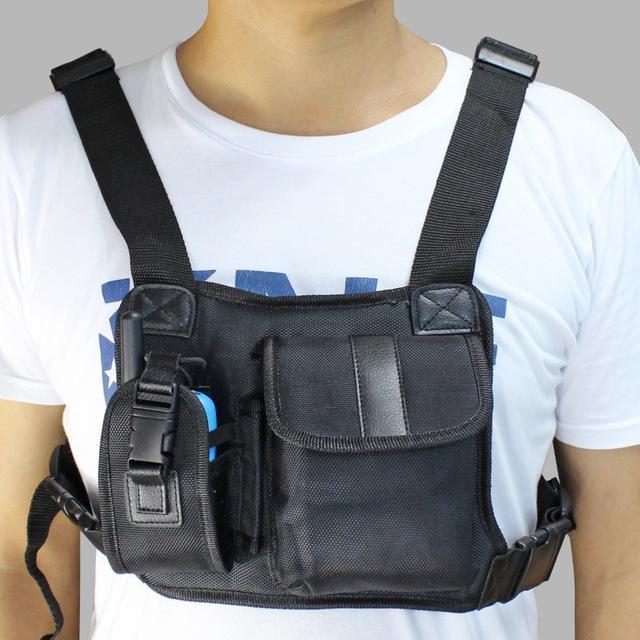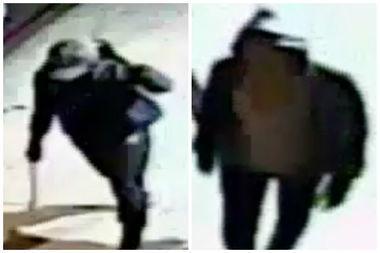The first image is the image on the left, the second image is the image on the right. Considering the images on both sides, is "The left and right image contains the same number of men." valid? Answer yes or no. No. 